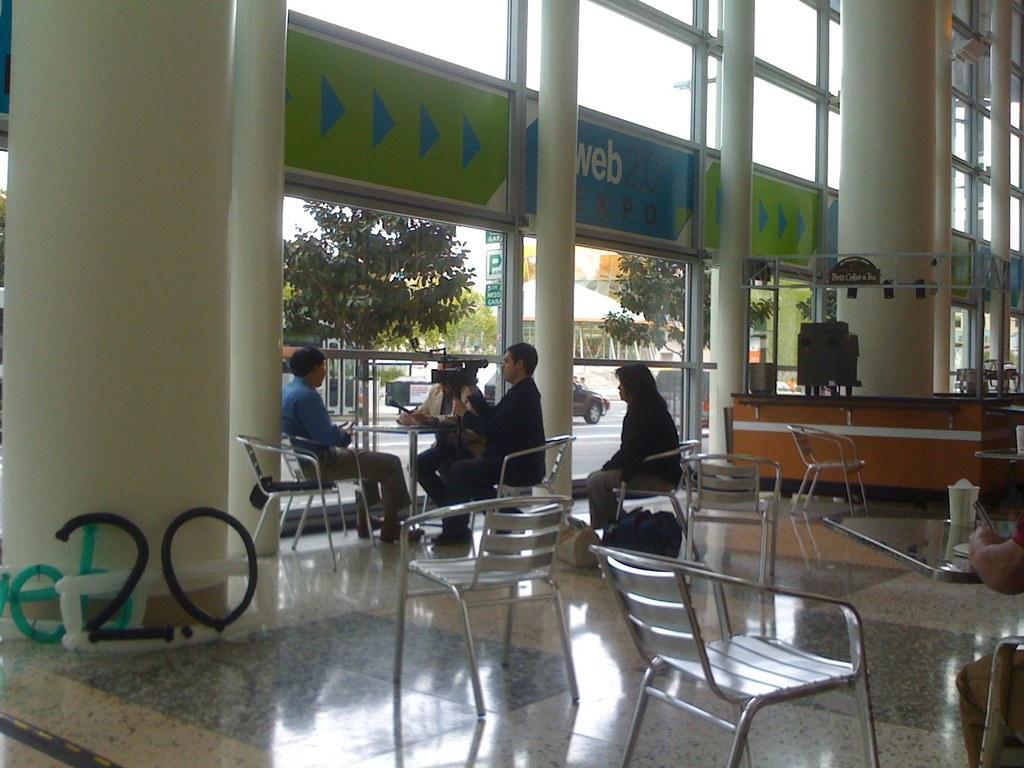Could you give a brief overview of what you see in this image? In this image we can see a group of people sitting on the chairs beside a table. In that a person is holding a camera with a stand and the other is holding a mic. We can also see some chairs and a table with some objects on it. On the left side we can see some text and numbers. On the backside we can see some pillars, the metal poles, trees, vehicles on the road, a roof with some poles, the signboards and the sky which looks cloudy. 